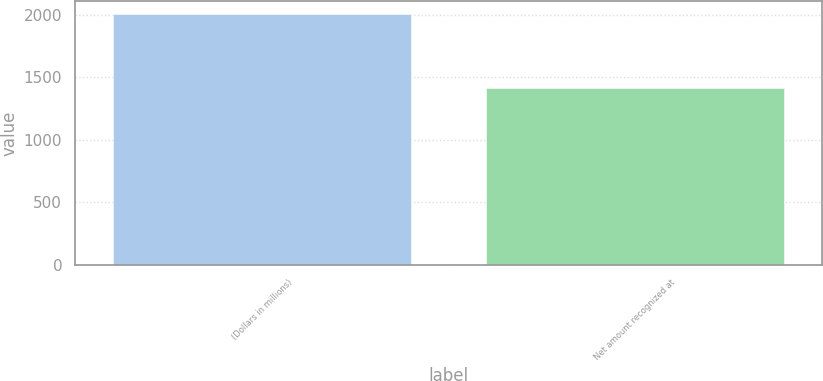<chart> <loc_0><loc_0><loc_500><loc_500><bar_chart><fcel>(Dollars in millions)<fcel>Net amount recognized at<nl><fcel>2007<fcel>1411<nl></chart> 